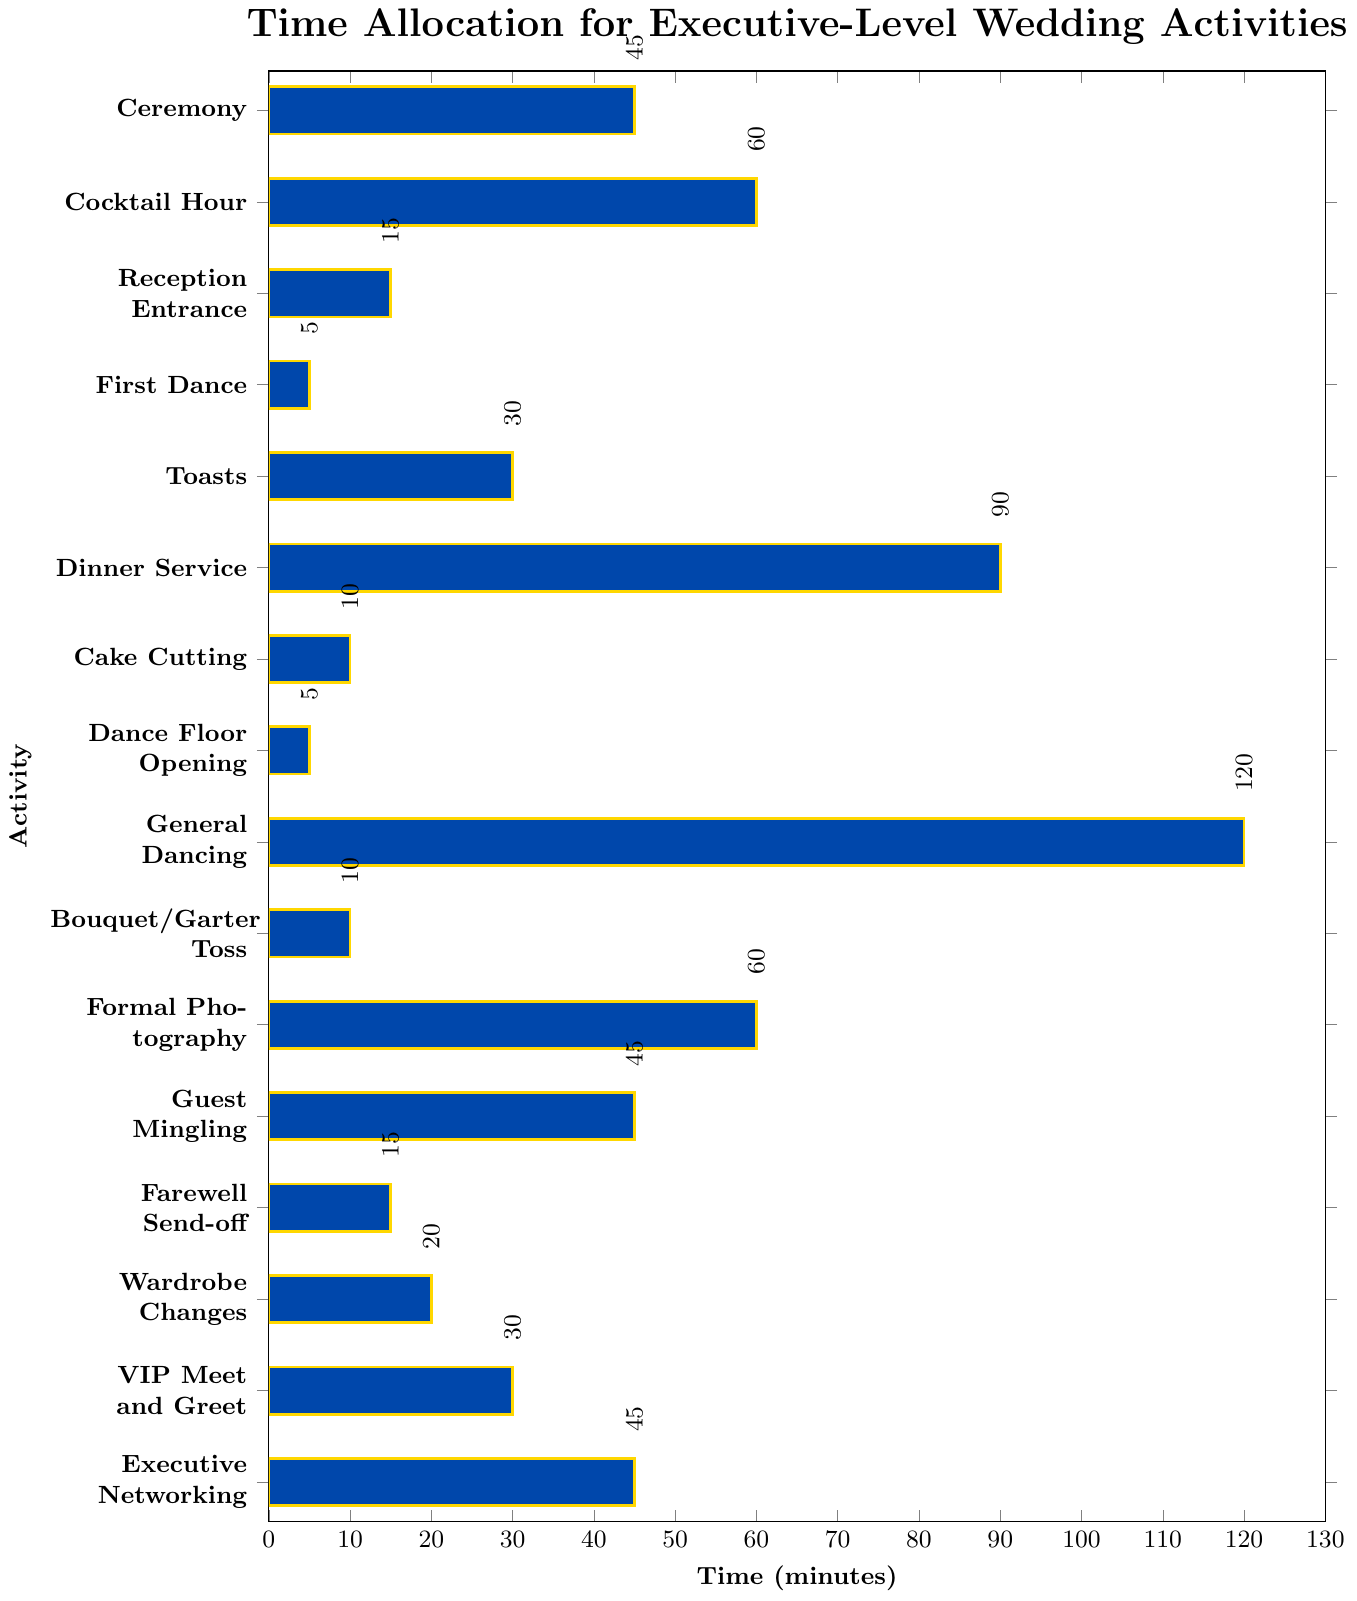Which activity takes the longest time? The figure shows time allocation visually with each activity represented by a bar. The longest bar corresponds to "General Dancing," which allocates 120 minutes.
Answer: General Dancing What is the total time spent on both "Cocktail Hour" and "Formal Photography"? The "Cocktail Hour" allocates 60 minutes, and "Formal Photography" also allocates 60 minutes. Adding them together, 60 + 60 equals 120 minutes.
Answer: 120 minutes How much longer is "Dinner Service" compared to "Reception Entrance"? "Dinner Service" is allocated 90 minutes and "Reception Entrance" is allocated 15 minutes. Subtracting the latter from the former, 90 - 15 equals 75 minutes.
Answer: 75 minutes Which activities are allocated 45 minutes? By observing the chart, "Ceremony," "Guest Mingling," and "Executive Networking" are each given a bar of equal length corresponding to 45 minutes.
Answer: Ceremony, Guest Mingling, Executive Networking What is the average time spent on "First Dance," "Cake Cutting," and "Bouquet/Garter Toss"? "First Dance" is 5 minutes, "Cake Cutting" is 10 minutes, and "Bouquet/Garter Toss" is 10 minutes. Adding them together: 5 + 10 + 10 = 25 minutes. Dividing by 3, the average time is 25 / 3 ≈ 8.33 minutes.
Answer: 8.33 minutes Which activity has a time allocation equal to the sum of "Wardrobe Changes" and "Farewell Send-off"? "Wardrobe Changes" is 20 minutes and "Farewell Send-off" is 15 minutes. Summing the two: 20 + 15 is 35 minutes. By checking the chart, no activity is exactly 35 minutes.
Answer: None Is the time spent on "Toasts" greater than "VIP Meet and Greet"? The chart shows "Toasts" is allocated 30 minutes while "VIP Meet and Greet" is also 30 minutes. "30" is not greater than "30".
Answer: No How much time would an attendee spend in activities if they participated in "Ceremony," "Reception Entrance," and "Guest Mingling"? Summing the times: "Ceremony" (45 minutes), "Reception Entrance" (15 minutes), and "Guest Mingling" (45 minutes) gives 45 + 15 + 45 = 105 minutes.
Answer: 105 minutes Which activities have time allocations less than 10 minutes? Observing the figure, "First Dance" and "Dance Floor Opening" are both less than 10 minutes with 5 minutes each.
Answer: First Dance, Dance Floor Opening 